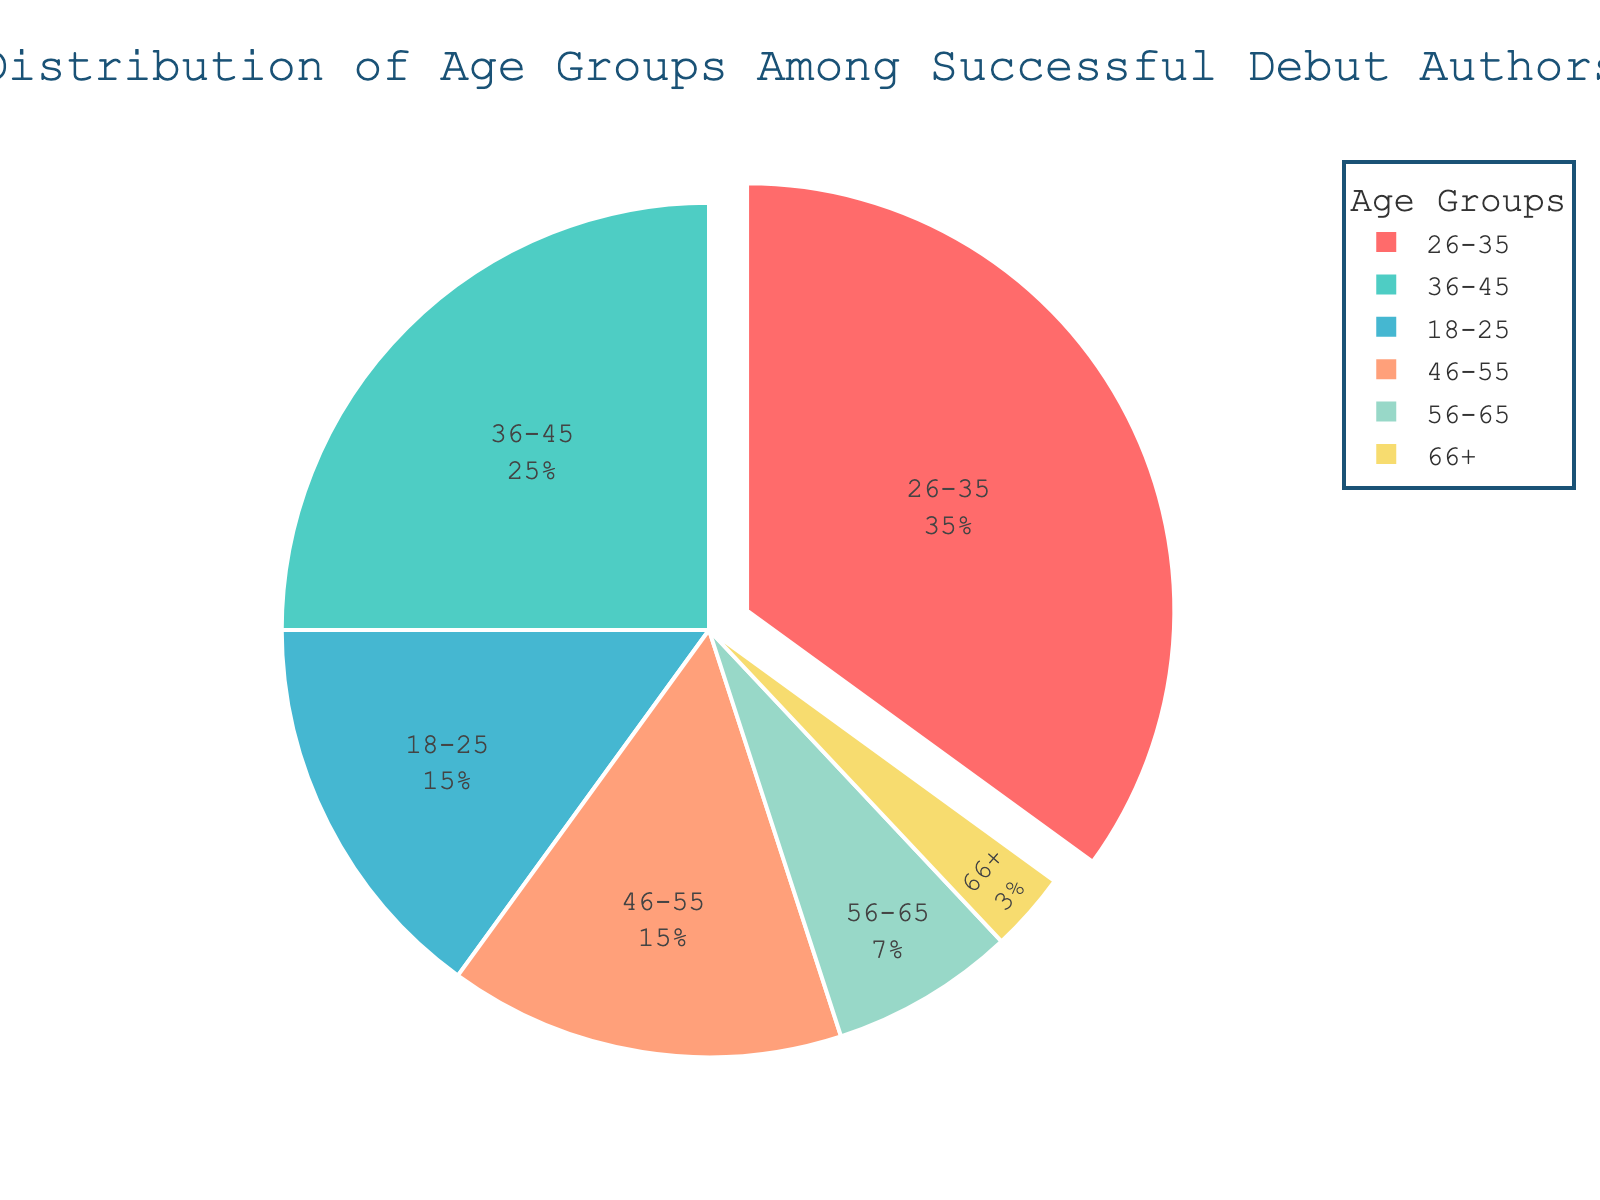What percentage of successful debut authors are aged between 18 to 25? Identify the section labeled "18-25" in the pie chart. The percentage can be read directly from the chart.
Answer: 15% Which age group has the largest representation among successful debut authors? Locate the largest section in the pie chart. The largest section represents the age group with the highest percentage.
Answer: 26-35 How do the combined percentages of the age groups 18-25 and 46-55 compare to the 26-35 group? Sum the percentages of the 18-25 and 46-55 groups (15% + 15%) and compare them to the percentage of the 26-35 group (35%).
Answer: 30% is less than 35% What is the difference in percentage between authors aged 36-45 and those aged 56-65? Subtract the percentage of the 56-65 group (7%) from the percentage of the 36-45 group (25%).
Answer: 18% What is the combined percentage of all age groups above 45? Sum the percentages of the 46-55, 56-65, and 66+ groups (15% + 7% + 3%).
Answer: 25% Which age group has the smallest percentage among successful debut authors? Identify the smallest section in the pie chart. The smallest section represents the age group with the lowest percentage.
Answer: 66+ How many age groups have a percentage greater than or equal to 25%? Identify sections that have a percentage of 25% or higher on the pie chart. Count these sections.
Answer: 2 What visual indicator is used to highlight the age group with the highest percentage? Observe the visual attributes of the largest section in the pie chart. Look for any special visual effects applied to that section.
Answer: It is pulled out slightly What is the sum of the percentages for the youngest and oldest age groups? Sum the percentages of the 18-25 (15%) and 66+ (3%) groups.
Answer: 18% Which color represents the age group 36-45 in the pie chart? Identify the section labeled "36-45" and note its color.
Answer: Light blue 